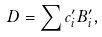<formula> <loc_0><loc_0><loc_500><loc_500>D = \sum c _ { i } ^ { \prime } B _ { i } ^ { \prime } ,</formula> 